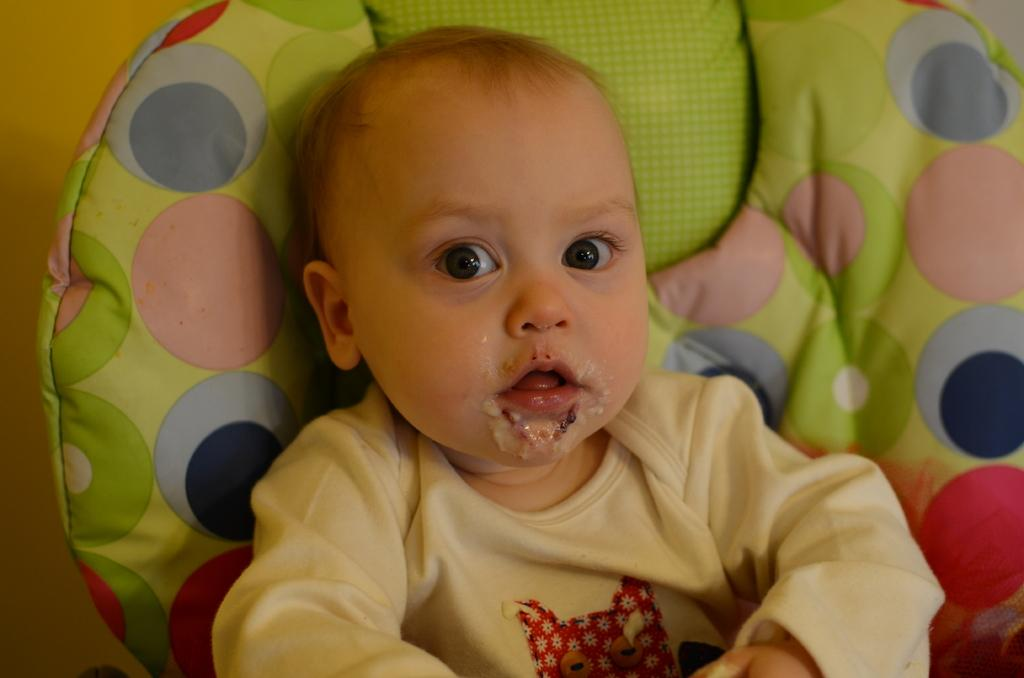What is the main subject of the image? The main subject of the image is a baby boy. Where is the baby boy located in the image? The baby boy is sitting on a sofa. What is the baby boy wearing in the image? The baby boy is wearing a T-shirt. What type of badge is the baby boy wearing in the image? There is no badge present in the image. What religion does the baby boy follow in the image? There is no indication of the baby boy's religion in the image. 